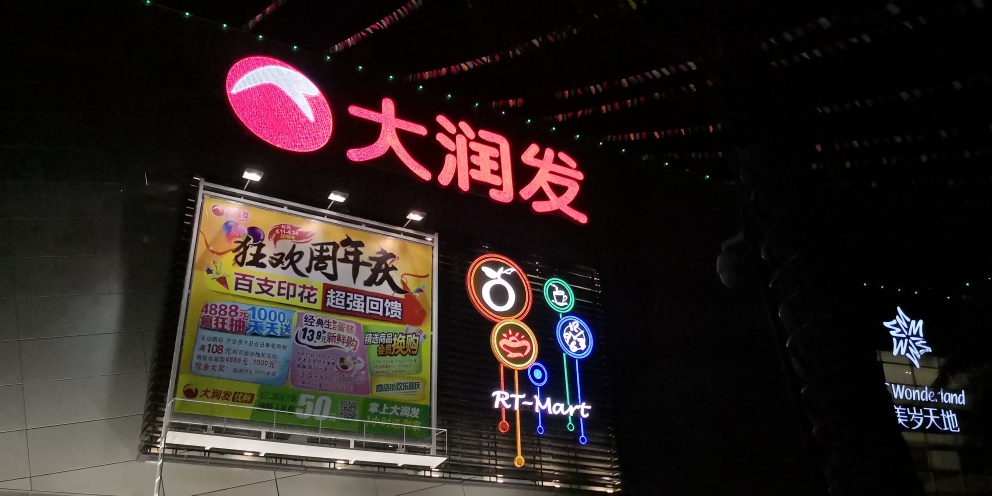What is the quality of this image? The quality of the image can be considered average due to several factors: the picture is taken at night with mixed lighting conditions, and the resulting image appears to have some noise and lack of sharpness that may affect the details. However, the signage is clearly readable, and the colors are vibrant, contributing to an overall acceptable quality. 